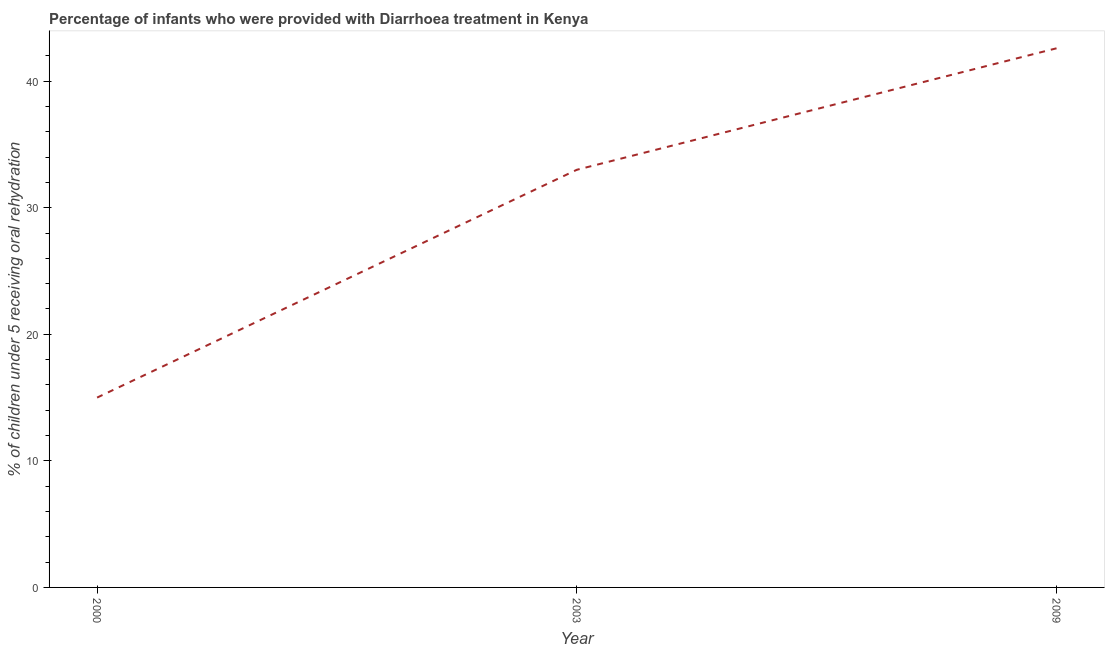What is the percentage of children who were provided with treatment diarrhoea in 2000?
Ensure brevity in your answer.  15. Across all years, what is the maximum percentage of children who were provided with treatment diarrhoea?
Give a very brief answer. 42.6. Across all years, what is the minimum percentage of children who were provided with treatment diarrhoea?
Offer a terse response. 15. What is the sum of the percentage of children who were provided with treatment diarrhoea?
Offer a terse response. 90.6. What is the difference between the percentage of children who were provided with treatment diarrhoea in 2000 and 2009?
Offer a very short reply. -27.6. What is the average percentage of children who were provided with treatment diarrhoea per year?
Your answer should be very brief. 30.2. What is the median percentage of children who were provided with treatment diarrhoea?
Your answer should be very brief. 33. In how many years, is the percentage of children who were provided with treatment diarrhoea greater than 30 %?
Ensure brevity in your answer.  2. Do a majority of the years between 2003 and 2000 (inclusive) have percentage of children who were provided with treatment diarrhoea greater than 28 %?
Keep it short and to the point. No. What is the ratio of the percentage of children who were provided with treatment diarrhoea in 2000 to that in 2003?
Ensure brevity in your answer.  0.45. Is the percentage of children who were provided with treatment diarrhoea in 2000 less than that in 2003?
Your response must be concise. Yes. What is the difference between the highest and the second highest percentage of children who were provided with treatment diarrhoea?
Make the answer very short. 9.6. Is the sum of the percentage of children who were provided with treatment diarrhoea in 2000 and 2009 greater than the maximum percentage of children who were provided with treatment diarrhoea across all years?
Offer a very short reply. Yes. What is the difference between the highest and the lowest percentage of children who were provided with treatment diarrhoea?
Provide a succinct answer. 27.6. How many lines are there?
Provide a short and direct response. 1. What is the difference between two consecutive major ticks on the Y-axis?
Provide a succinct answer. 10. Are the values on the major ticks of Y-axis written in scientific E-notation?
Ensure brevity in your answer.  No. Does the graph contain grids?
Offer a very short reply. No. What is the title of the graph?
Offer a terse response. Percentage of infants who were provided with Diarrhoea treatment in Kenya. What is the label or title of the X-axis?
Offer a terse response. Year. What is the label or title of the Y-axis?
Your response must be concise. % of children under 5 receiving oral rehydration. What is the % of children under 5 receiving oral rehydration in 2000?
Your answer should be very brief. 15. What is the % of children under 5 receiving oral rehydration of 2003?
Give a very brief answer. 33. What is the % of children under 5 receiving oral rehydration of 2009?
Make the answer very short. 42.6. What is the difference between the % of children under 5 receiving oral rehydration in 2000 and 2009?
Ensure brevity in your answer.  -27.6. What is the difference between the % of children under 5 receiving oral rehydration in 2003 and 2009?
Make the answer very short. -9.6. What is the ratio of the % of children under 5 receiving oral rehydration in 2000 to that in 2003?
Provide a short and direct response. 0.46. What is the ratio of the % of children under 5 receiving oral rehydration in 2000 to that in 2009?
Offer a very short reply. 0.35. What is the ratio of the % of children under 5 receiving oral rehydration in 2003 to that in 2009?
Provide a short and direct response. 0.78. 